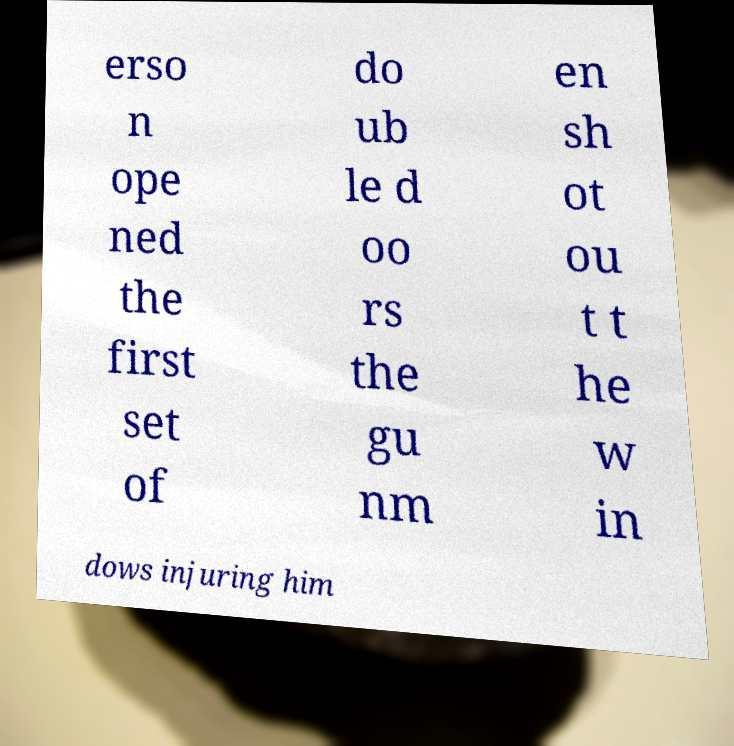Can you read and provide the text displayed in the image?This photo seems to have some interesting text. Can you extract and type it out for me? erso n ope ned the first set of do ub le d oo rs the gu nm en sh ot ou t t he w in dows injuring him 